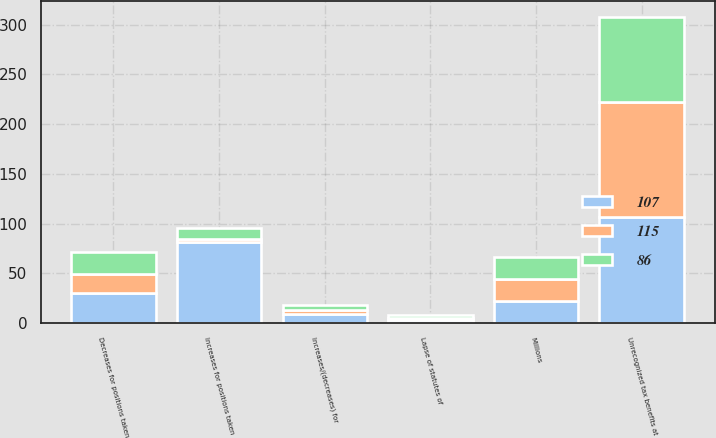<chart> <loc_0><loc_0><loc_500><loc_500><stacked_bar_chart><ecel><fcel>Millions<fcel>Unrecognized tax benefits at<fcel>Increases for positions taken<fcel>Decreases for positions taken<fcel>Increases/(decreases) for<fcel>Lapse of statutes of<nl><fcel>115<fcel>22<fcel>115<fcel>4<fcel>19<fcel>4<fcel>2<nl><fcel>107<fcel>22<fcel>107<fcel>81<fcel>30<fcel>9<fcel>3<nl><fcel>86<fcel>22<fcel>86<fcel>11<fcel>22<fcel>5<fcel>3<nl></chart> 